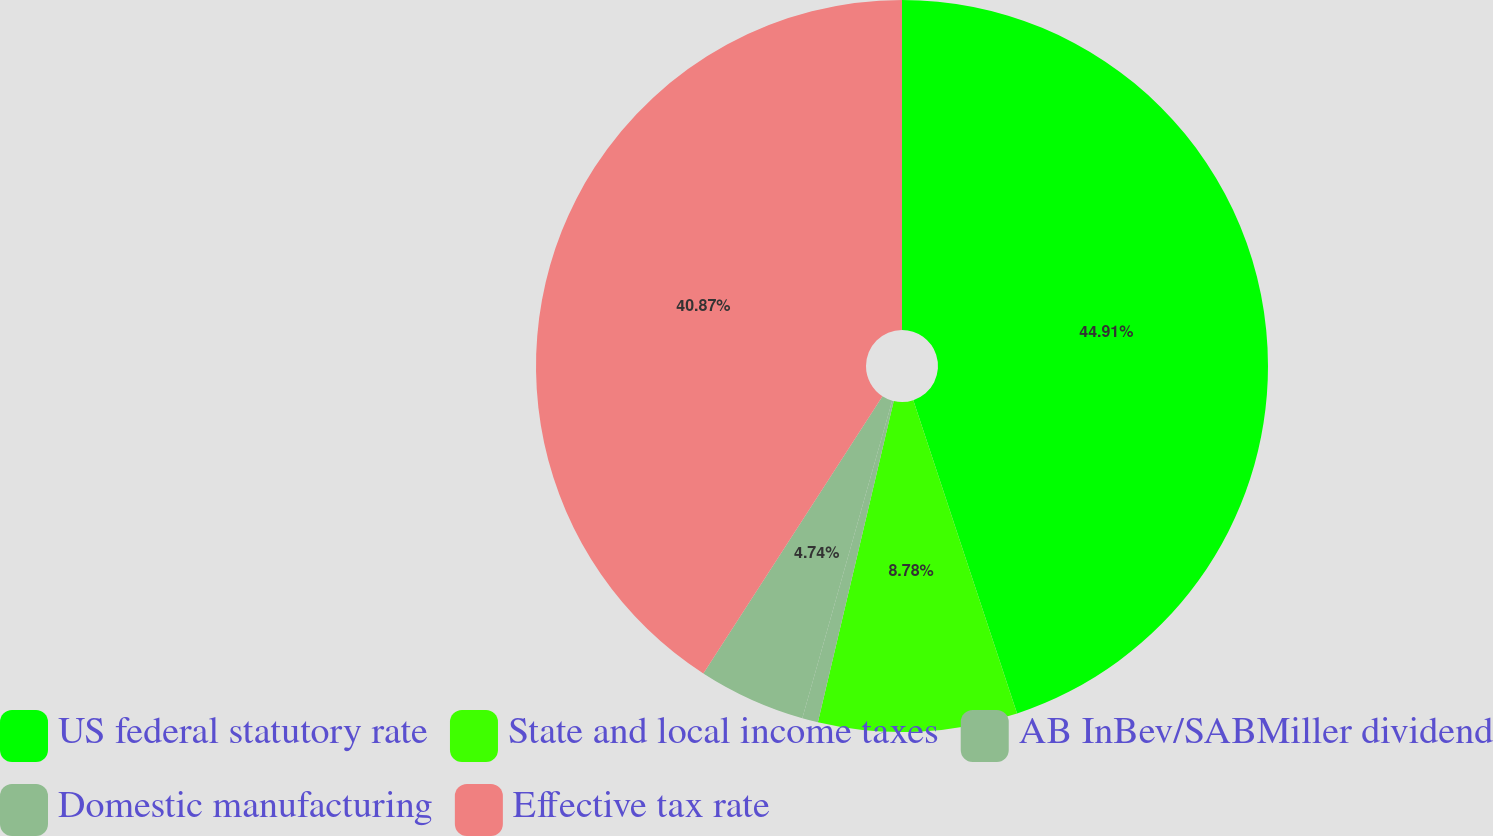<chart> <loc_0><loc_0><loc_500><loc_500><pie_chart><fcel>US federal statutory rate<fcel>State and local income taxes<fcel>AB InBev/SABMiller dividend<fcel>Domestic manufacturing<fcel>Effective tax rate<nl><fcel>44.9%<fcel>8.78%<fcel>0.7%<fcel>4.74%<fcel>40.86%<nl></chart> 